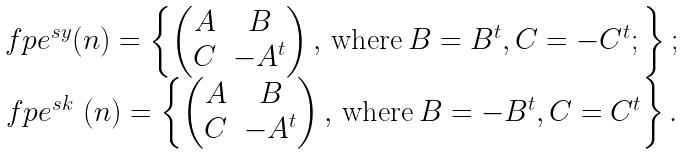Convert formula to latex. <formula><loc_0><loc_0><loc_500><loc_500>\begin{matrix} \ f p e ^ { s y } ( n ) = \left \{ \begin{pmatrix} A & B \\ C & - A ^ { t } \end{pmatrix} , \, \text {where} \, B = B ^ { t } , C = - C ^ { t } ; \right \} ; \\ \ f p e ^ { s k } \ ( n ) = \left \{ \begin{pmatrix} A & B \\ C & - A ^ { t } \end{pmatrix} , \, \text {where} \, B = - B ^ { t } , C = C ^ { t } \right \} . \end{matrix}</formula> 